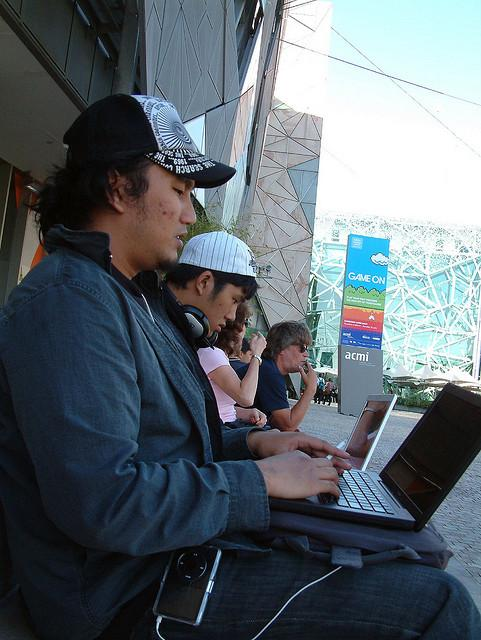What race is the man closest to the camera? asian 